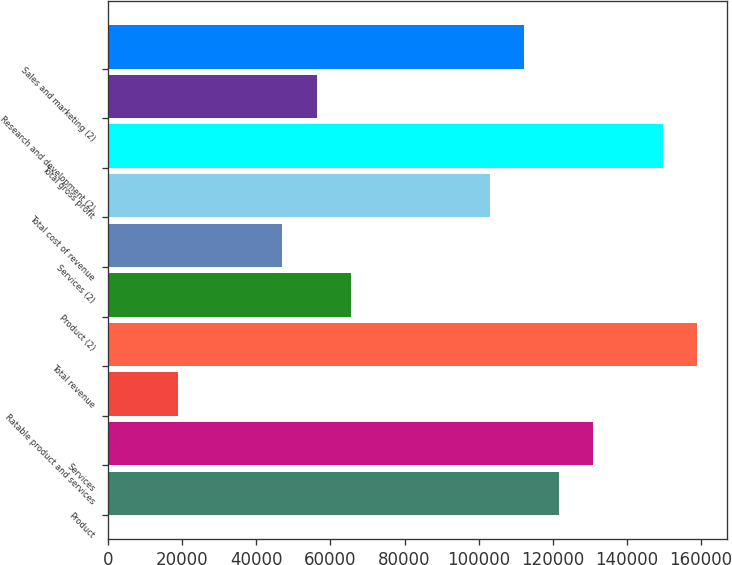Convert chart. <chart><loc_0><loc_0><loc_500><loc_500><bar_chart><fcel>Product<fcel>Services<fcel>Ratable product and services<fcel>Total revenue<fcel>Product (2)<fcel>Services (2)<fcel>Total cost of revenue<fcel>Total gross profit<fcel>Research and development (2)<fcel>Sales and marketing (2)<nl><fcel>121604<fcel>130939<fcel>18919.8<fcel>158943<fcel>65594.3<fcel>46924.5<fcel>102934<fcel>149608<fcel>56259.4<fcel>112269<nl></chart> 